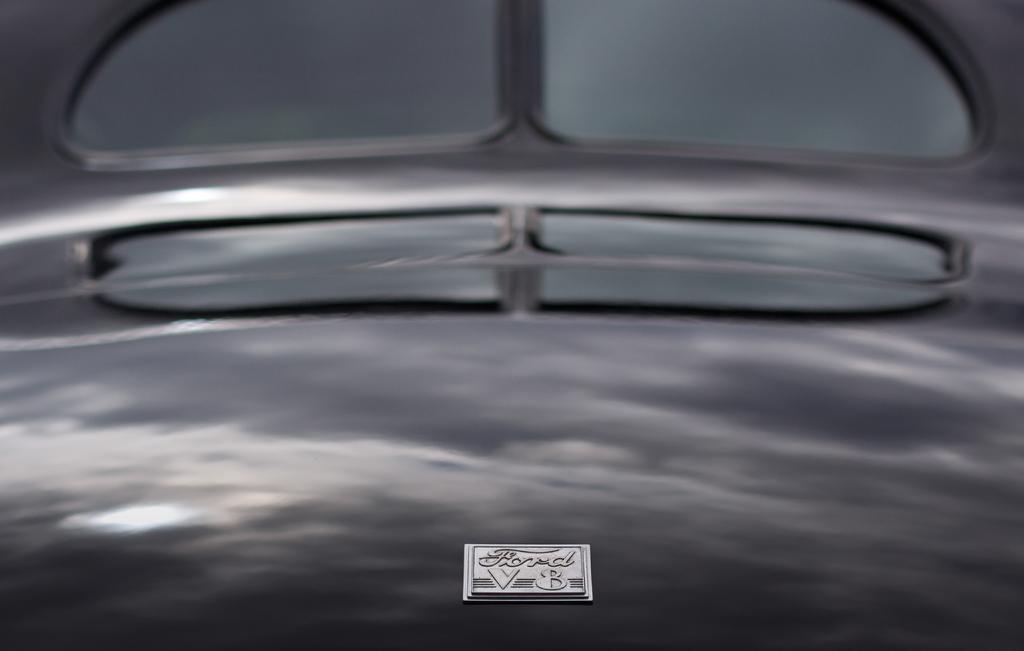Could you give a brief overview of what you see in this image? In this image I can see the vehicle. I can see the reflection of clouds and sky on the vehicle. 